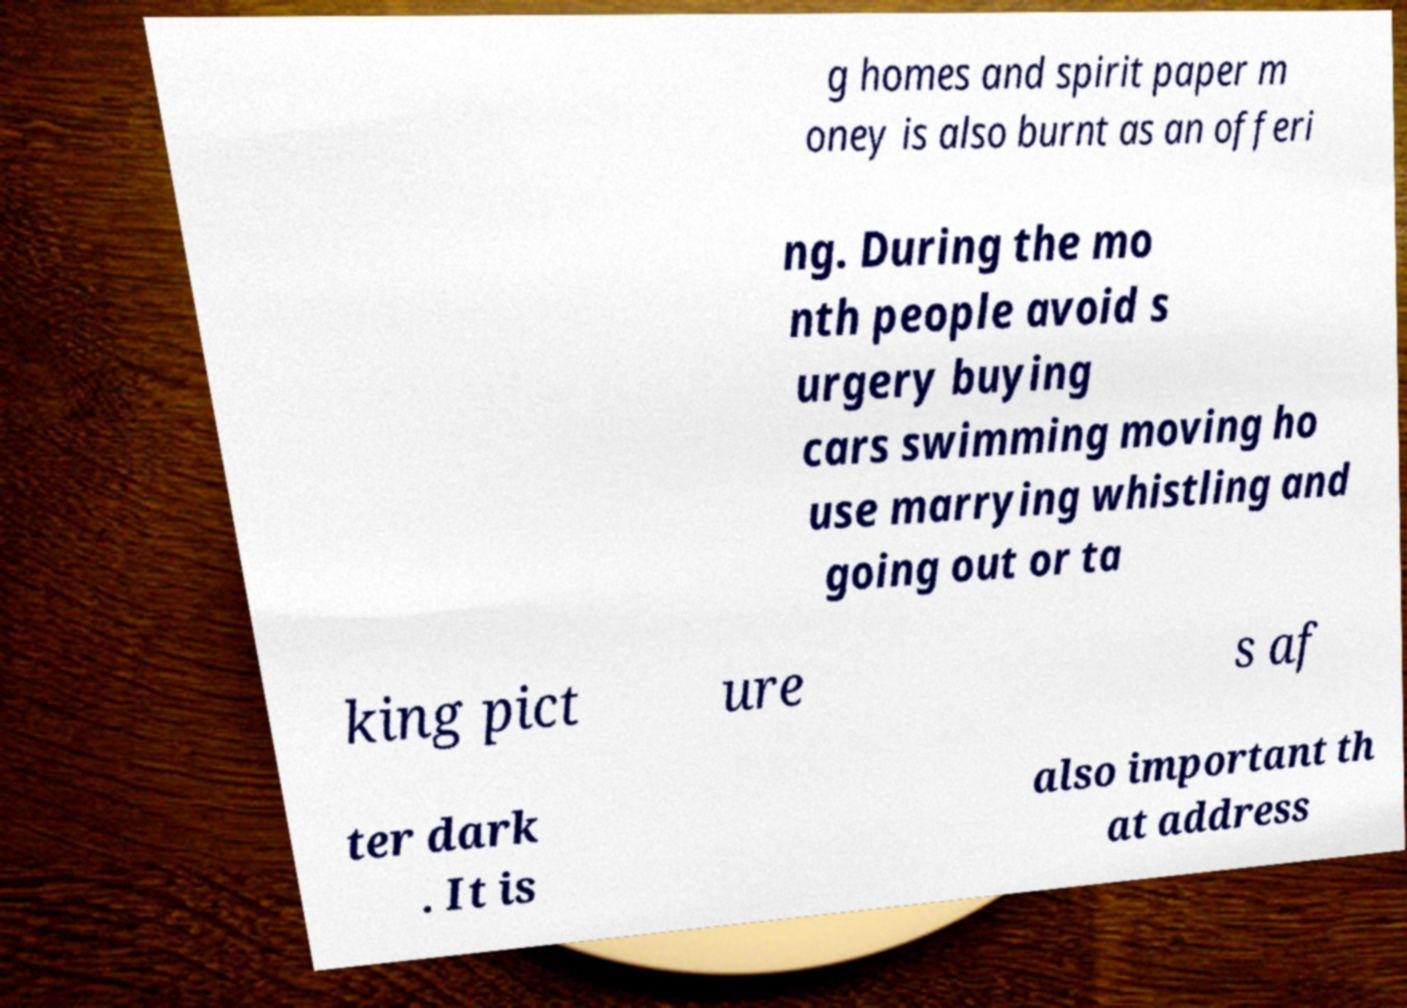What messages or text are displayed in this image? I need them in a readable, typed format. g homes and spirit paper m oney is also burnt as an offeri ng. During the mo nth people avoid s urgery buying cars swimming moving ho use marrying whistling and going out or ta king pict ure s af ter dark . It is also important th at address 